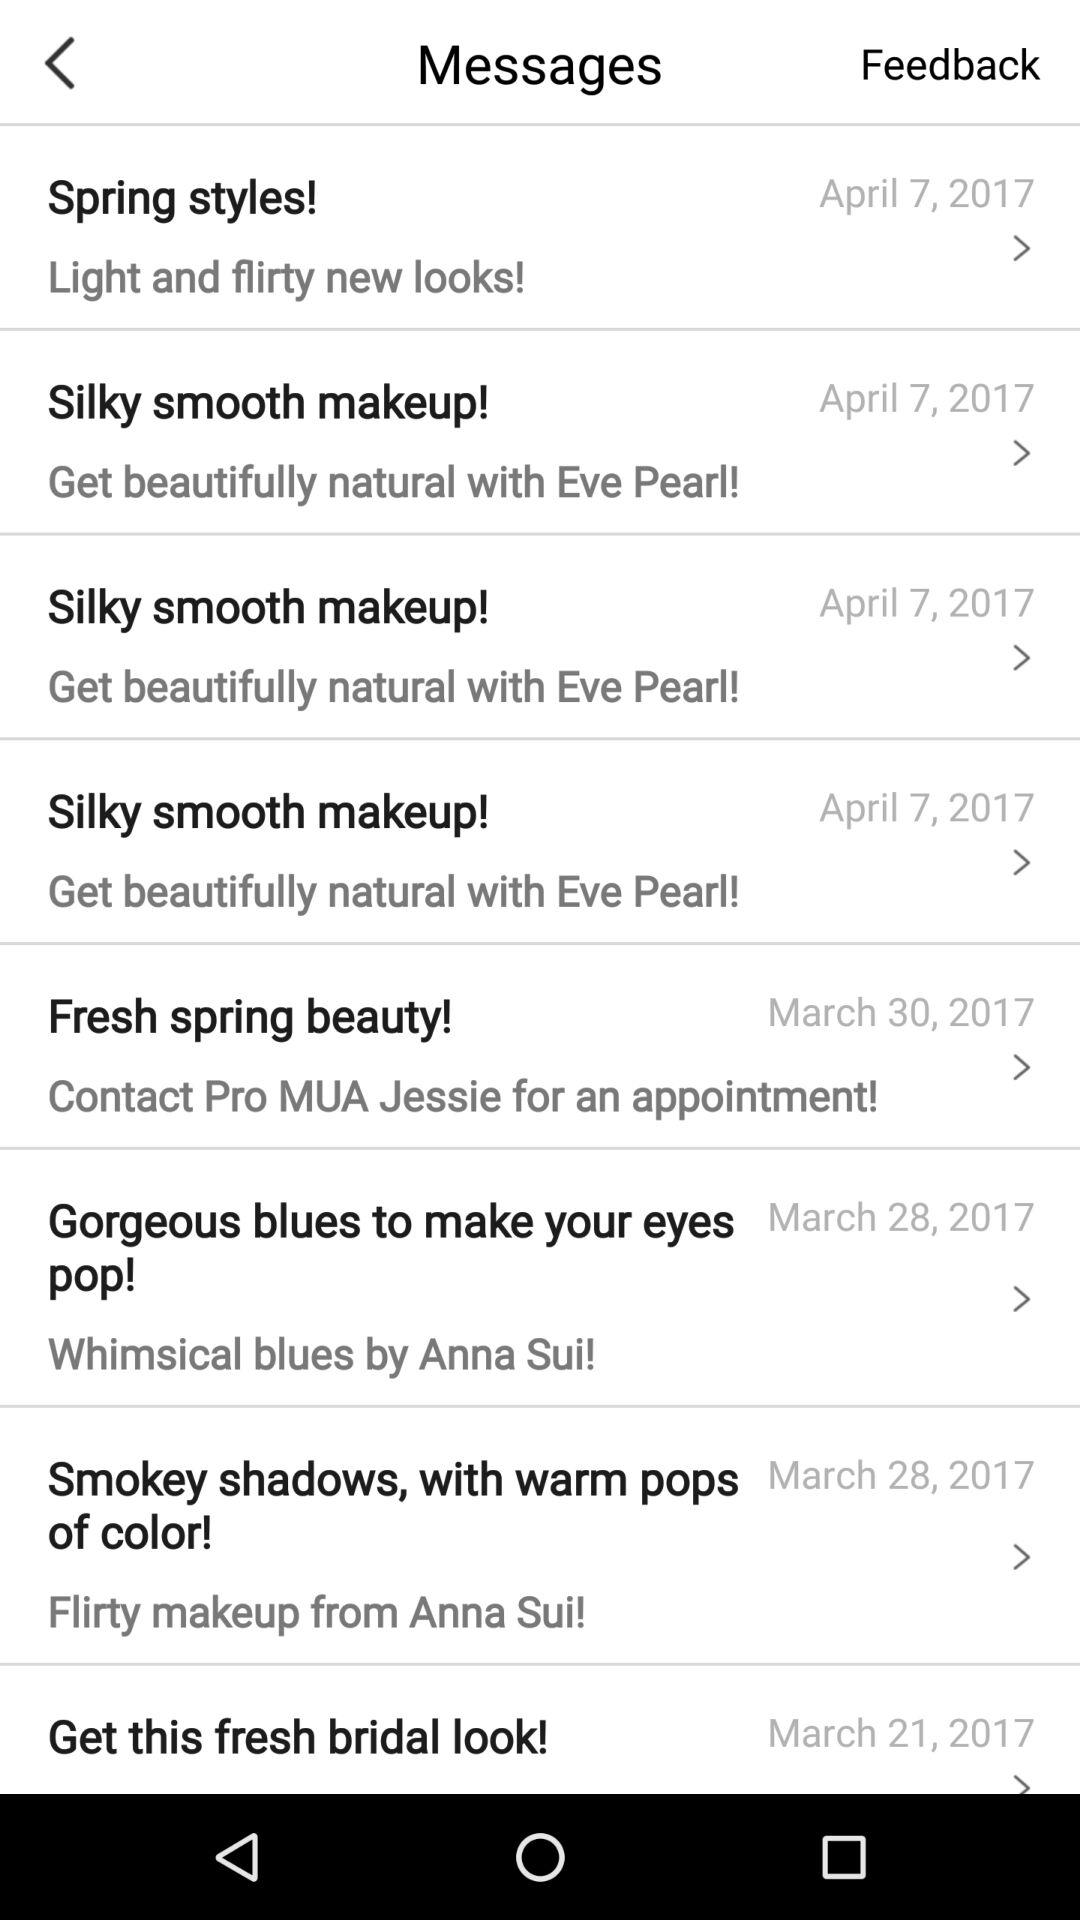What time was "Fresh spring beauty!" sent?
When the provided information is insufficient, respond with <no answer>. <no answer> 